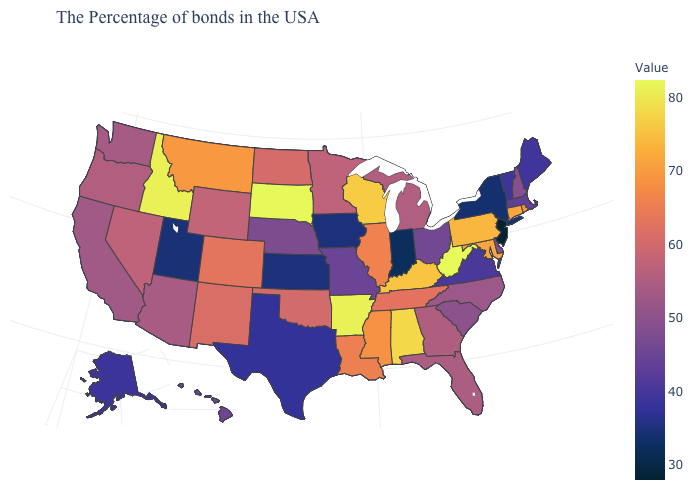Which states have the lowest value in the USA?
Write a very short answer. New Jersey. Is the legend a continuous bar?
Be succinct. Yes. Does the map have missing data?
Keep it brief. No. Which states hav the highest value in the West?
Answer briefly. Idaho. 